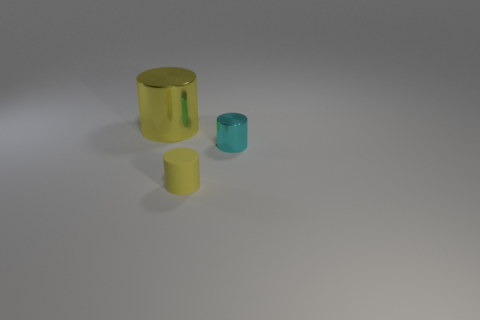How many small cylinders have the same color as the rubber thing?
Offer a terse response. 0. What is the color of the small shiny object that is the same shape as the big yellow object?
Make the answer very short. Cyan. Are there more gray metallic cubes than yellow matte cylinders?
Provide a succinct answer. No. What is the material of the small cyan cylinder?
Your answer should be compact. Metal. Is there any other thing that has the same size as the cyan shiny object?
Your answer should be compact. Yes. There is a yellow shiny object that is the same shape as the rubber object; what size is it?
Give a very brief answer. Large. There is a metal thing on the right side of the yellow shiny cylinder; is there a object that is behind it?
Your response must be concise. Yes. Do the matte thing and the tiny shiny cylinder have the same color?
Provide a succinct answer. No. Are there more yellow rubber cylinders on the right side of the tiny cyan shiny thing than big metallic cylinders that are right of the big yellow thing?
Offer a very short reply. No. There is a cylinder on the left side of the yellow matte thing; is it the same size as the yellow thing on the right side of the large yellow object?
Provide a succinct answer. No. 